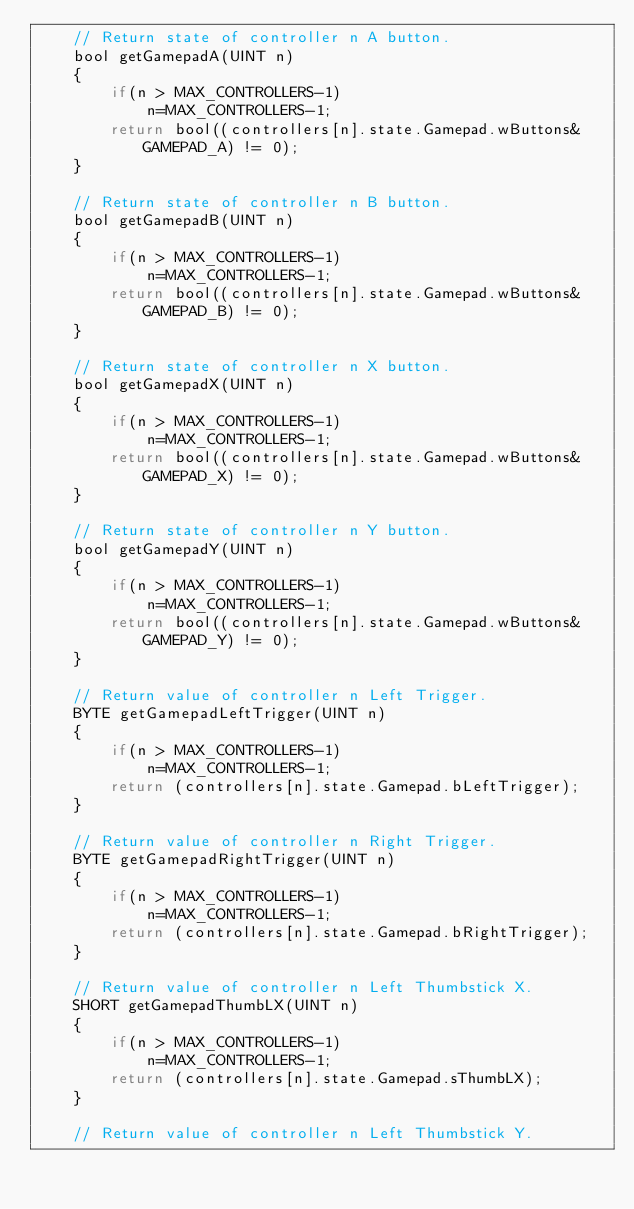<code> <loc_0><loc_0><loc_500><loc_500><_C_>    // Return state of controller n A button.
    bool getGamepadA(UINT n) 
    {
        if(n > MAX_CONTROLLERS-1)
            n=MAX_CONTROLLERS-1;
        return bool((controllers[n].state.Gamepad.wButtons&GAMEPAD_A) != 0);
    }

    // Return state of controller n B button.
    bool getGamepadB(UINT n) 
    {
        if(n > MAX_CONTROLLERS-1)
            n=MAX_CONTROLLERS-1;
        return bool((controllers[n].state.Gamepad.wButtons&GAMEPAD_B) != 0);
    }

    // Return state of controller n X button.
    bool getGamepadX(UINT n) 
    {
        if(n > MAX_CONTROLLERS-1)
            n=MAX_CONTROLLERS-1;
        return bool((controllers[n].state.Gamepad.wButtons&GAMEPAD_X) != 0);
    }

    // Return state of controller n Y button.
    bool getGamepadY(UINT n) 
    {
        if(n > MAX_CONTROLLERS-1)
            n=MAX_CONTROLLERS-1;
        return bool((controllers[n].state.Gamepad.wButtons&GAMEPAD_Y) != 0);
    }

    // Return value of controller n Left Trigger.
    BYTE getGamepadLeftTrigger(UINT n) 
    {
        if(n > MAX_CONTROLLERS-1)
            n=MAX_CONTROLLERS-1;
        return (controllers[n].state.Gamepad.bLeftTrigger);
    }

    // Return value of controller n Right Trigger.
    BYTE getGamepadRightTrigger(UINT n) 
    {
        if(n > MAX_CONTROLLERS-1)
            n=MAX_CONTROLLERS-1;
        return (controllers[n].state.Gamepad.bRightTrigger);
    }

    // Return value of controller n Left Thumbstick X.
    SHORT getGamepadThumbLX(UINT n) 
    {
        if(n > MAX_CONTROLLERS-1)
            n=MAX_CONTROLLERS-1;
        return (controllers[n].state.Gamepad.sThumbLX);
    }

    // Return value of controller n Left Thumbstick Y.</code> 